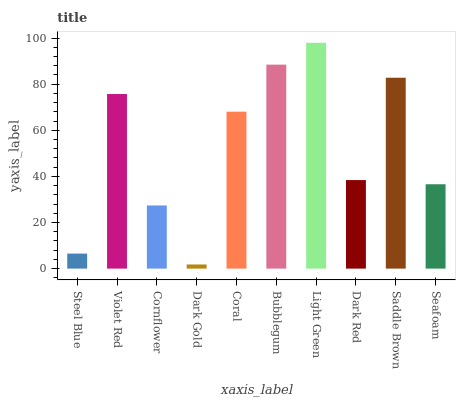Is Dark Gold the minimum?
Answer yes or no. Yes. Is Light Green the maximum?
Answer yes or no. Yes. Is Violet Red the minimum?
Answer yes or no. No. Is Violet Red the maximum?
Answer yes or no. No. Is Violet Red greater than Steel Blue?
Answer yes or no. Yes. Is Steel Blue less than Violet Red?
Answer yes or no. Yes. Is Steel Blue greater than Violet Red?
Answer yes or no. No. Is Violet Red less than Steel Blue?
Answer yes or no. No. Is Coral the high median?
Answer yes or no. Yes. Is Dark Red the low median?
Answer yes or no. Yes. Is Seafoam the high median?
Answer yes or no. No. Is Cornflower the low median?
Answer yes or no. No. 